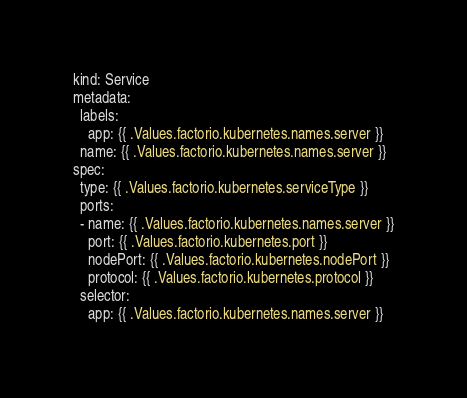Convert code to text. <code><loc_0><loc_0><loc_500><loc_500><_YAML_>kind: Service
metadata:
  labels:
    app: {{ .Values.factorio.kubernetes.names.server }}
  name: {{ .Values.factorio.kubernetes.names.server }}
spec:
  type: {{ .Values.factorio.kubernetes.serviceType }}
  ports:
  - name: {{ .Values.factorio.kubernetes.names.server }}
    port: {{ .Values.factorio.kubernetes.port }}
    nodePort: {{ .Values.factorio.kubernetes.nodePort }}
    protocol: {{ .Values.factorio.kubernetes.protocol }}
  selector:
    app: {{ .Values.factorio.kubernetes.names.server }}
</code> 